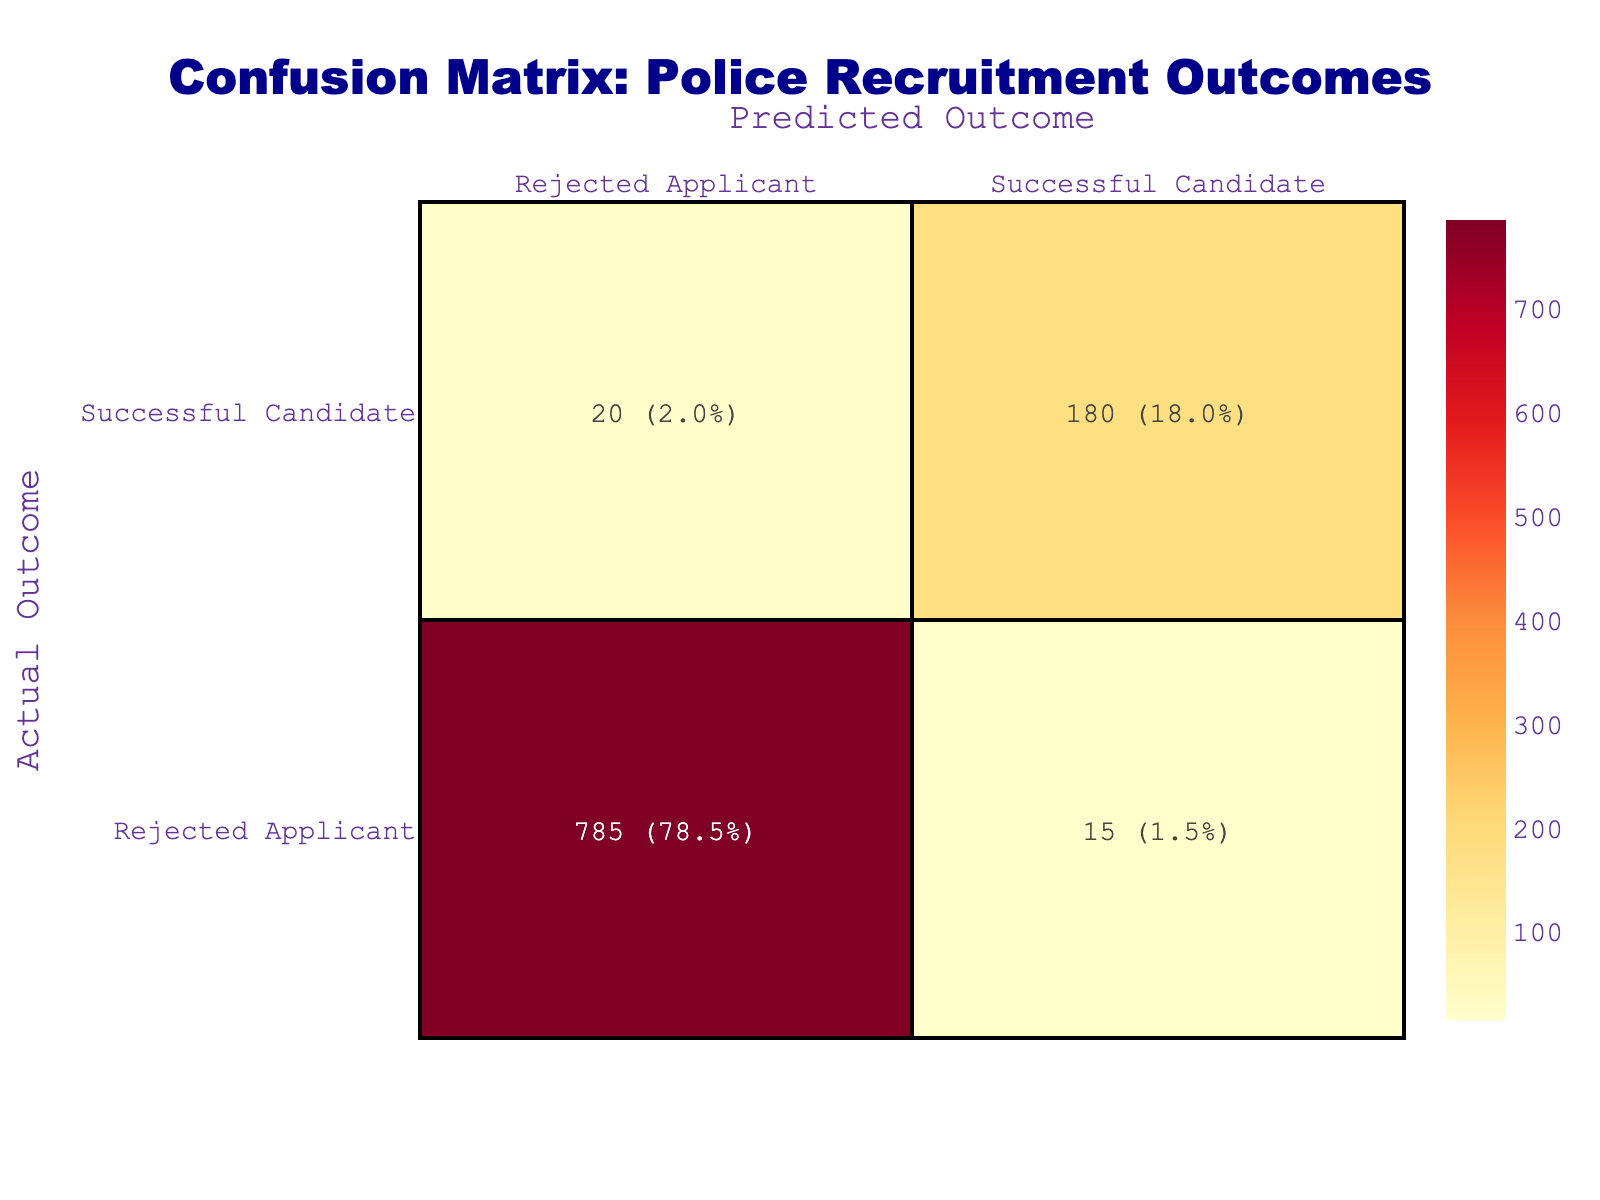What is the count of successful candidates predicted correctly? Looking at the table, under the "Actual Outcome" of "Successful Candidate," the "Predicted Outcome" of "Successful Candidate" has a count of 180.
Answer: 180 What is the total number of applicants who were actually successful? To find the total number of applicants who were successful, we sum the counts for "Successful Candidate" under the "Actual Outcome" row: 180 (predicted correctly) + 20 (predicted incorrectly) = 200.
Answer: 200 What percentage of rejected applicants was predicted as successful candidates? The total count of rejected applicants is 15 (predicted as successful) + 785 (predicted as rejected) = 800. The percentage of rejected applicants predicted as successful is (15/800) * 100 = 1.875%.
Answer: 1.9% Is it true that most successful candidates were predicted correctly? To determine this, we see that 180 candidates were correctly predicted as successful out of a total of 200 actual successful candidates. Since 180 is greater than half of 200, it is true.
Answer: Yes What is the difference in count between predicted successful candidates and rejected applicants? The count for predicted successful candidates is 180, and for rejected applicants, it is 785. The difference is 785 - 180 = 605.
Answer: 605 How many applicants were rejected both by actual and predicted outcomes? The count of applicants who were both actually and predicted as rejected is 785, which can be directly found in the table.
Answer: 785 What is the total count of applicants in this analysis? To find the total count of applicants, we add up all counts: 180 (correctly predicted) + 20 (incorrectly predicted) + 15 (incorrectly predicted) + 785 (correctly predicted) = 1000.
Answer: 1000 How many more applicants were correctly predicted as rejected than incorrectly predicted as successful? The count of correctly predicted as rejected is 785, while the count of incorrectly predicted as successful is 15. The difference is 785 - 15 = 770.
Answer: 770 Based on the predictions, did more applicants get rejected than accepted? The total number of applicants who got rejected (both correct and incorrect) is 15 (predicted as successful) + 785 (predicted as rejected) = 800; meanwhile, actual accepted candidates are 200. 800 is greater than 200, so yes.
Answer: Yes 